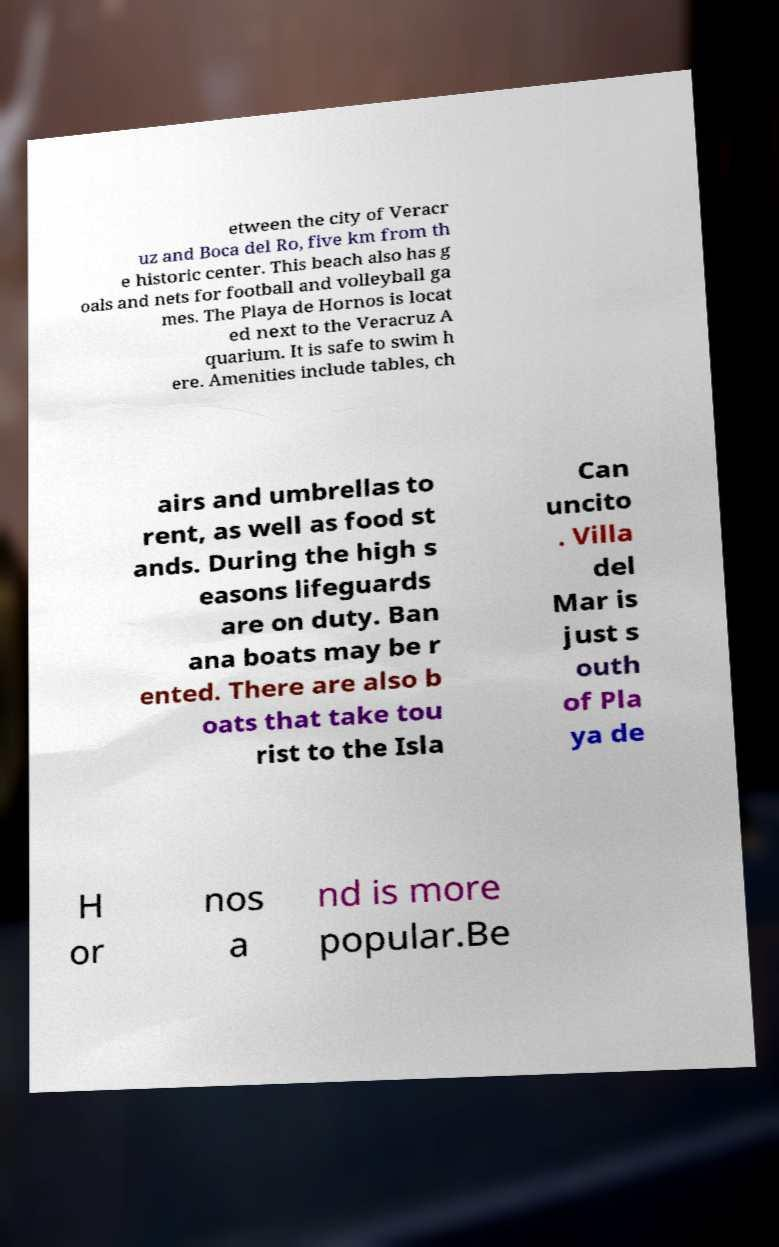For documentation purposes, I need the text within this image transcribed. Could you provide that? etween the city of Veracr uz and Boca del Ro, five km from th e historic center. This beach also has g oals and nets for football and volleyball ga mes. The Playa de Hornos is locat ed next to the Veracruz A quarium. It is safe to swim h ere. Amenities include tables, ch airs and umbrellas to rent, as well as food st ands. During the high s easons lifeguards are on duty. Ban ana boats may be r ented. There are also b oats that take tou rist to the Isla Can uncito . Villa del Mar is just s outh of Pla ya de H or nos a nd is more popular.Be 